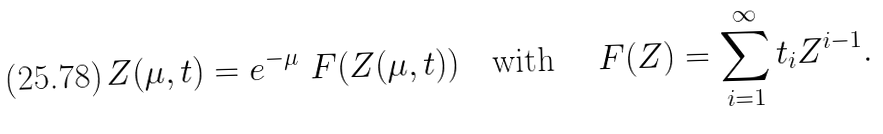<formula> <loc_0><loc_0><loc_500><loc_500>Z ( \mu , t ) = e ^ { - \mu } \ F ( Z ( \mu , t ) ) \quad \text {with} \quad \ F ( Z ) = \sum _ { i = 1 } ^ { \infty } t _ { i } Z ^ { i - 1 } .</formula> 